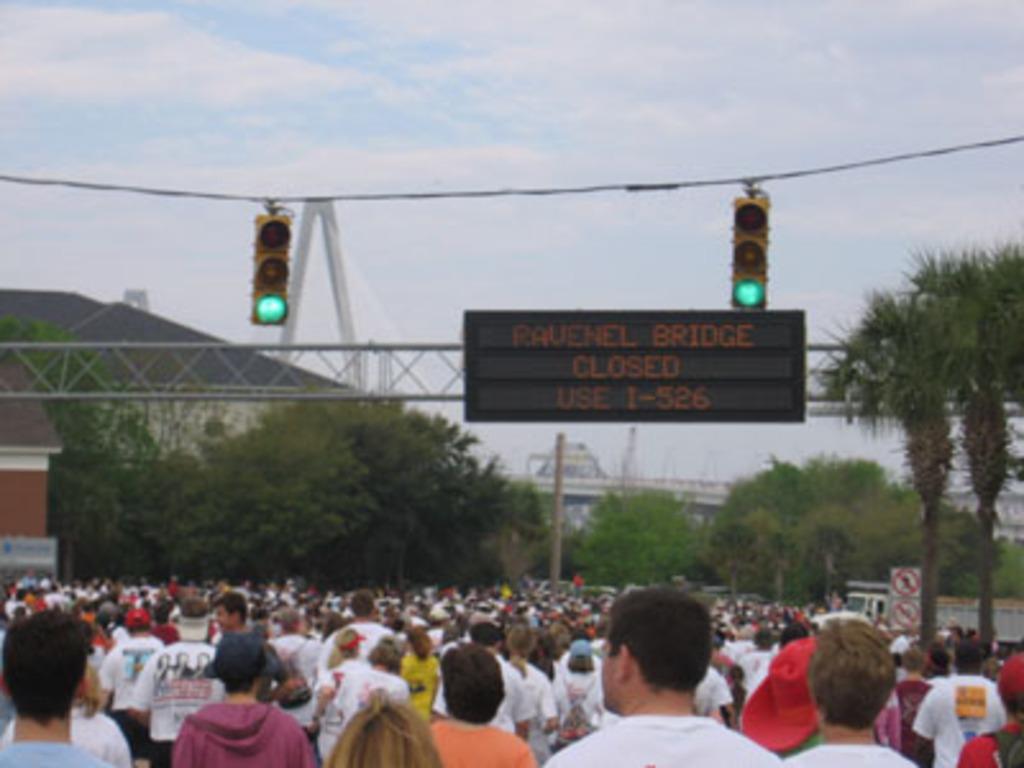Could you give a brief overview of what you see in this image? In this image in front there are people. In the center of the image there are traffic lights. There is a display board. In the background of the image there are trees, buildings and sky. On the right side of the image there are boards. 